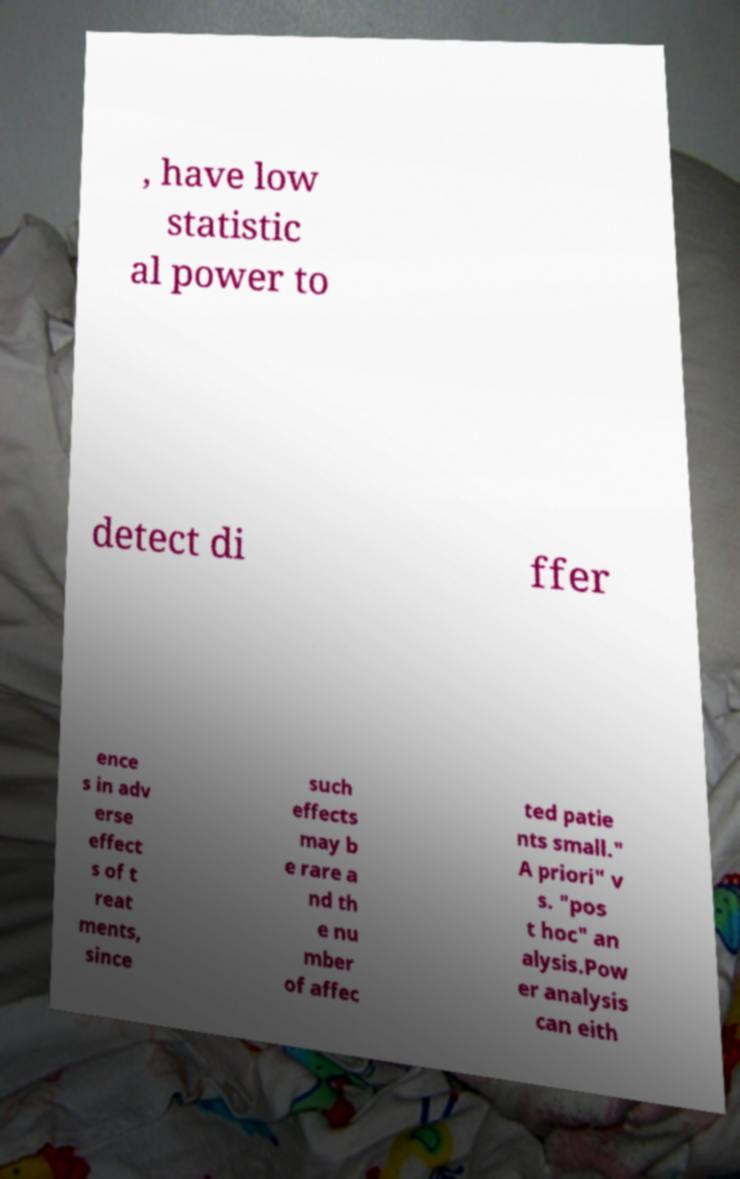Could you extract and type out the text from this image? , have low statistic al power to detect di ffer ence s in adv erse effect s of t reat ments, since such effects may b e rare a nd th e nu mber of affec ted patie nts small." A priori" v s. "pos t hoc" an alysis.Pow er analysis can eith 